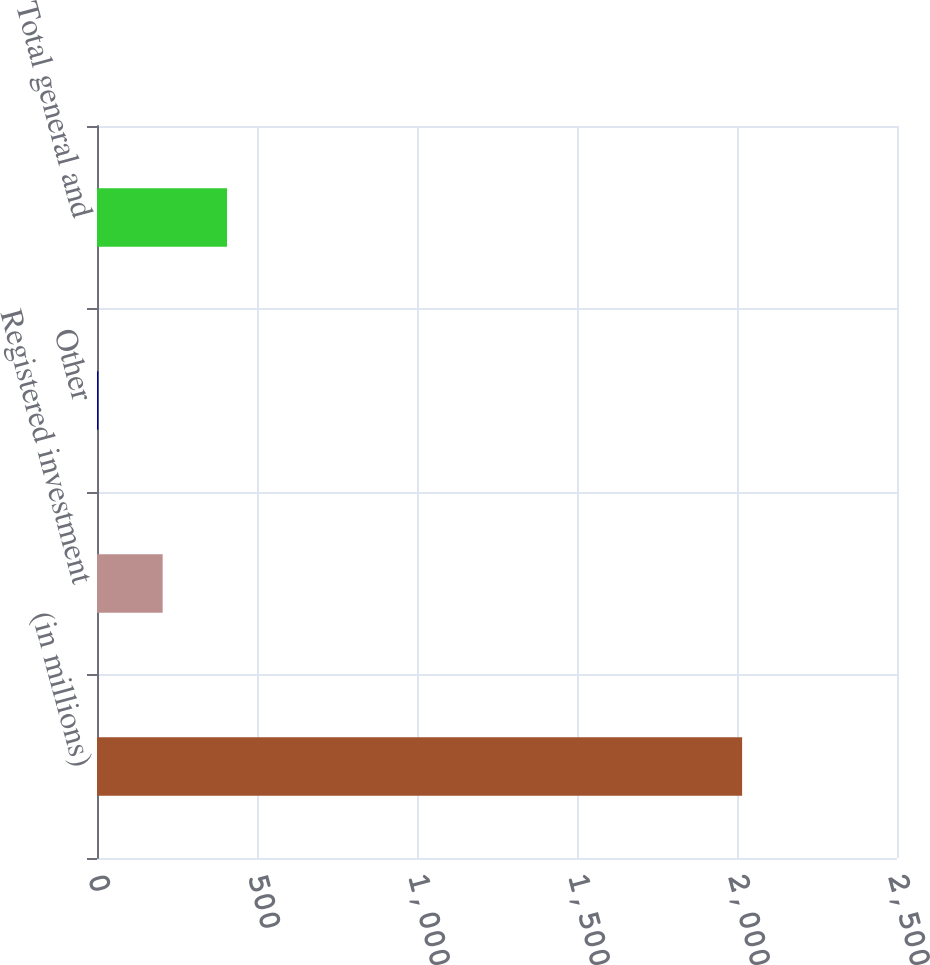Convert chart to OTSL. <chart><loc_0><loc_0><loc_500><loc_500><bar_chart><fcel>(in millions)<fcel>Registered investment<fcel>Other<fcel>Total general and<nl><fcel>2016<fcel>205.2<fcel>4<fcel>406.4<nl></chart> 